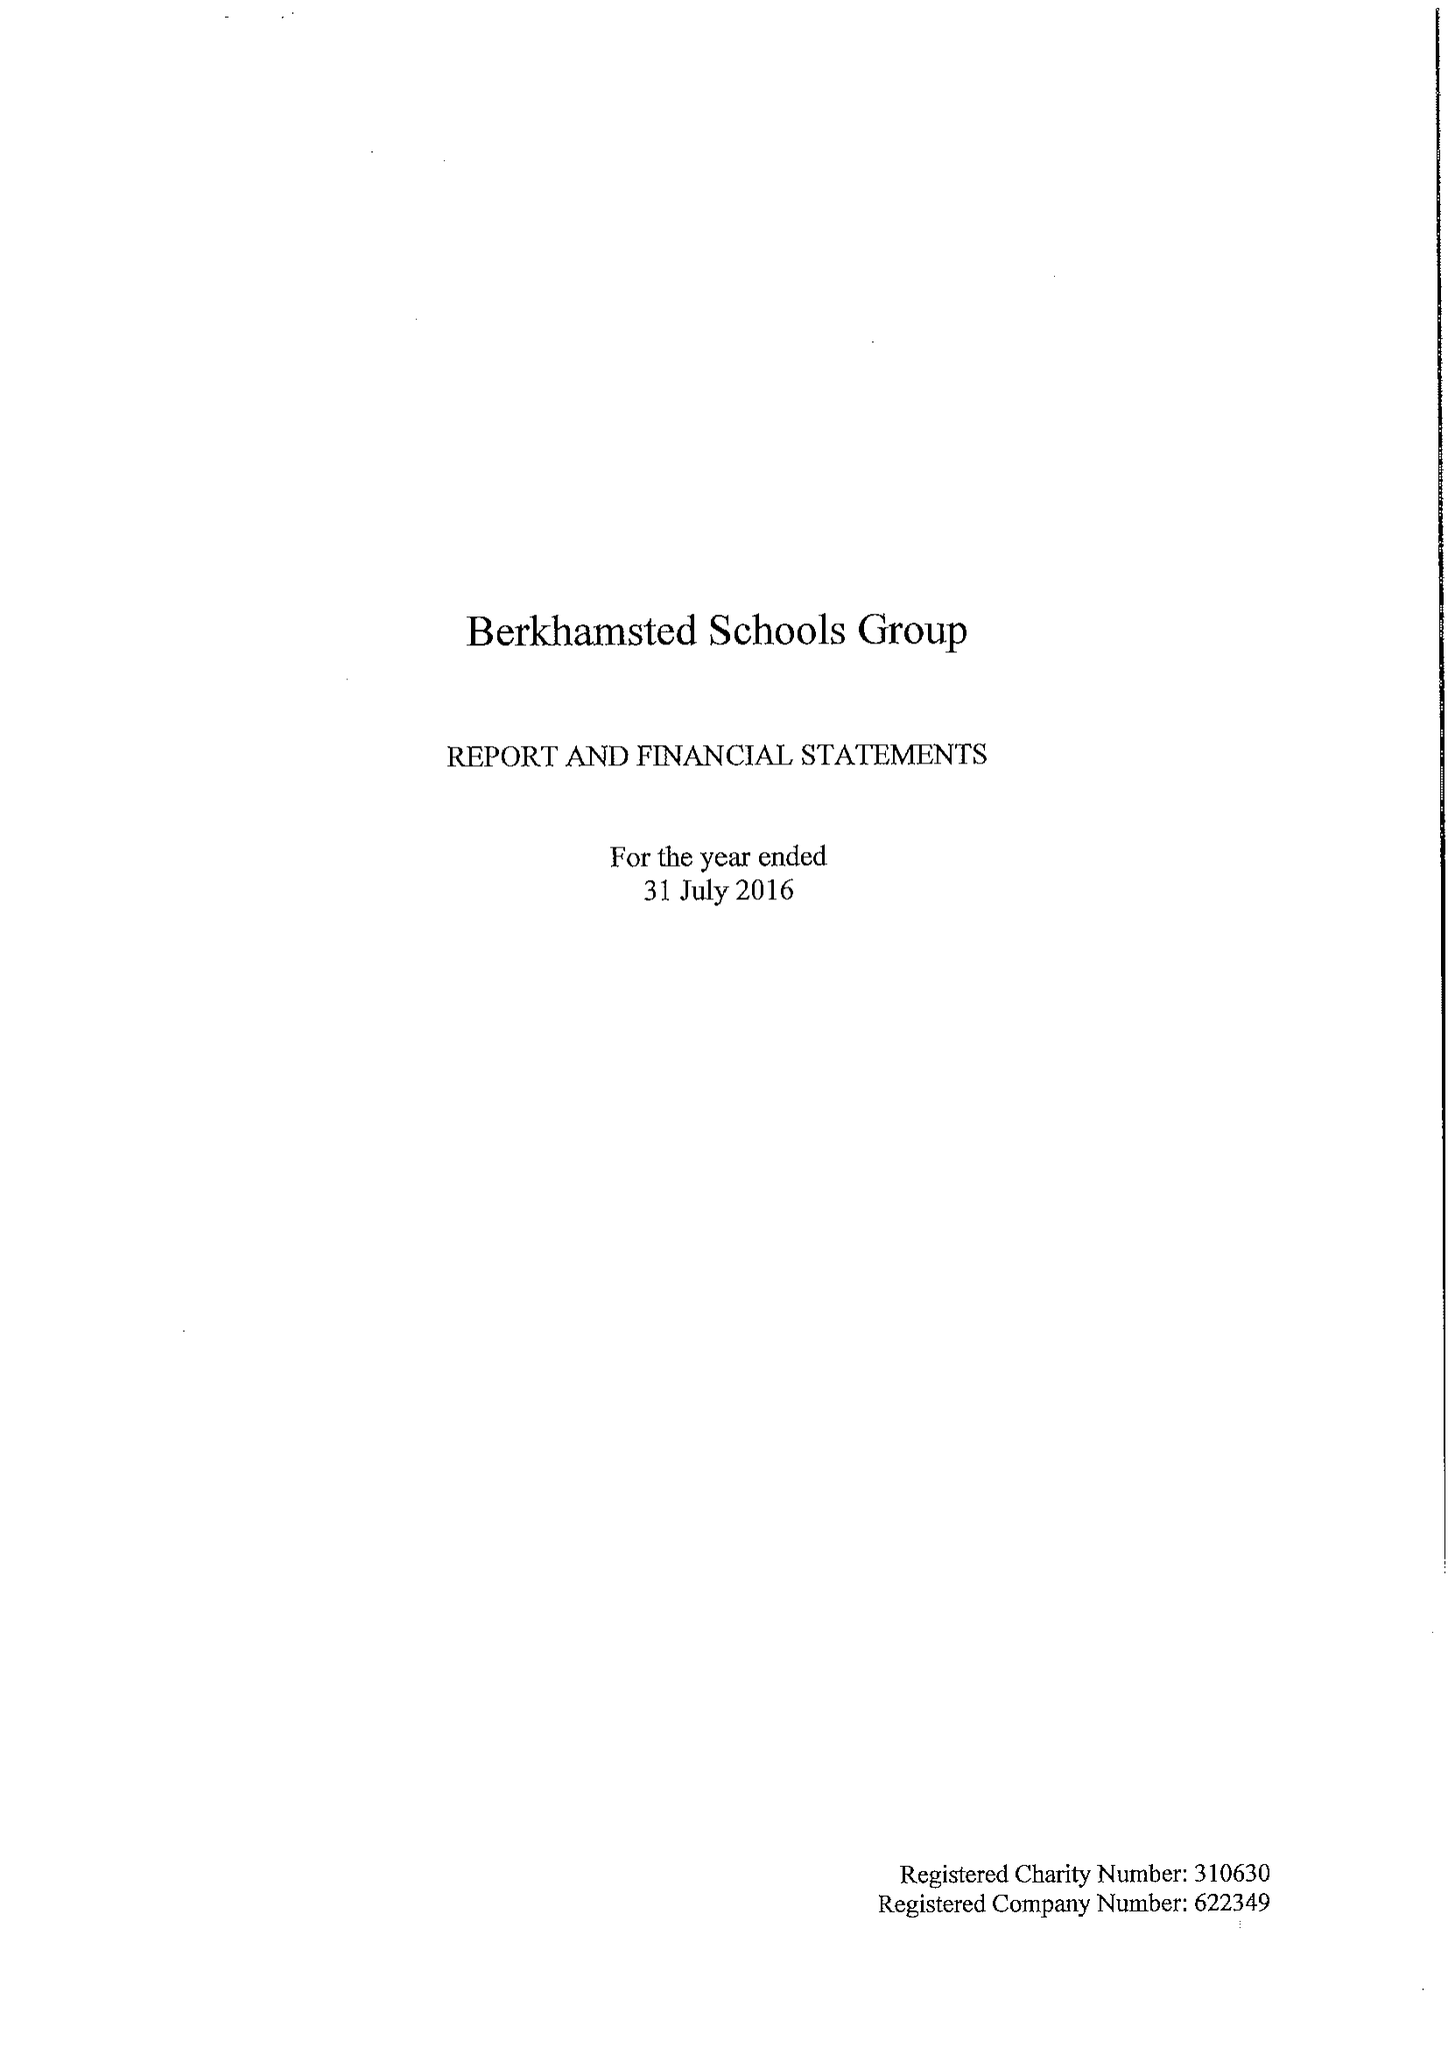What is the value for the spending_annually_in_british_pounds?
Answer the question using a single word or phrase. 28264000.00 